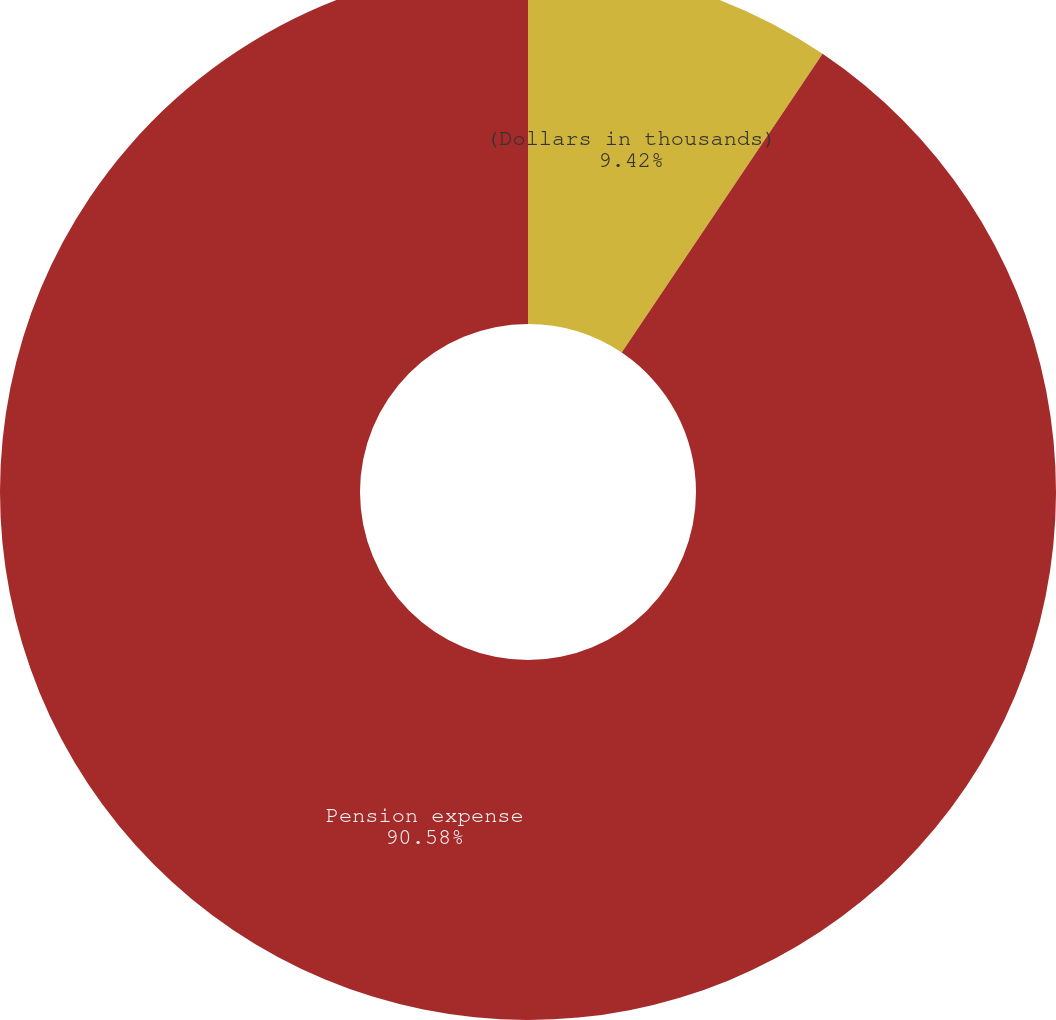Convert chart. <chart><loc_0><loc_0><loc_500><loc_500><pie_chart><fcel>(Dollars in thousands)<fcel>Pension expense<nl><fcel>9.42%<fcel>90.58%<nl></chart> 